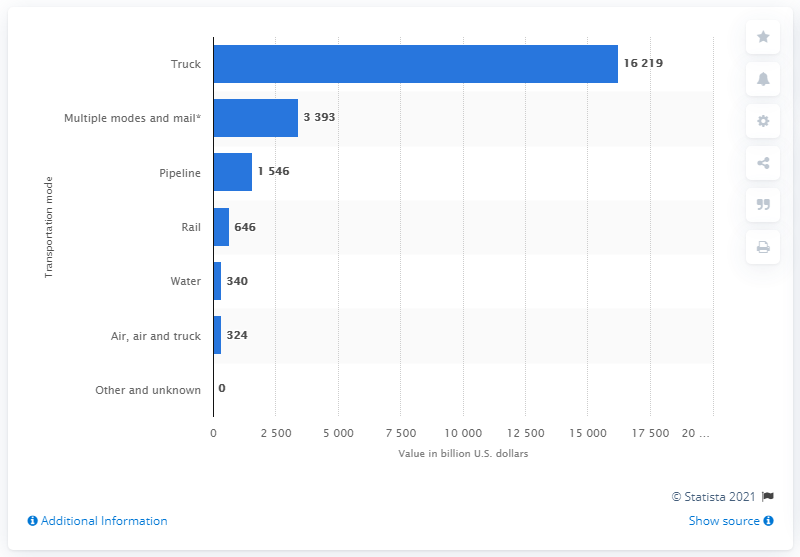Identify some key points in this picture. The estimated value of U.S. domestic shipments transported by rail in dollars is approximately 646... 